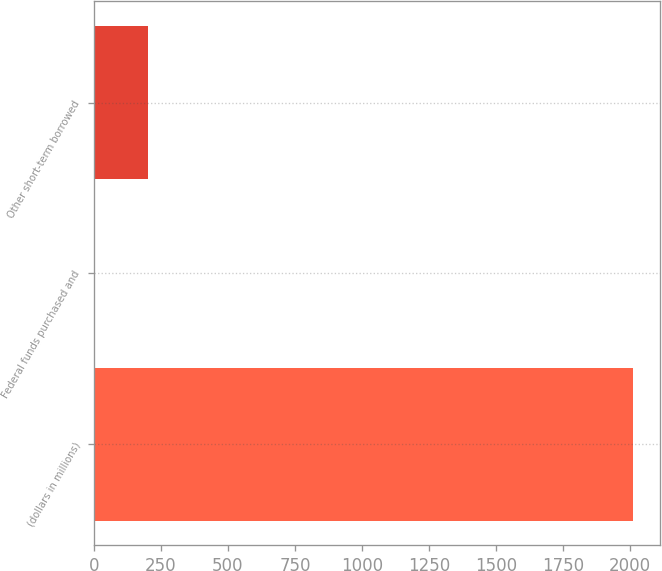Convert chart to OTSL. <chart><loc_0><loc_0><loc_500><loc_500><bar_chart><fcel>(dollars in millions)<fcel>Federal funds purchased and<fcel>Other short-term borrowed<nl><fcel>2012<fcel>0.1<fcel>201.29<nl></chart> 